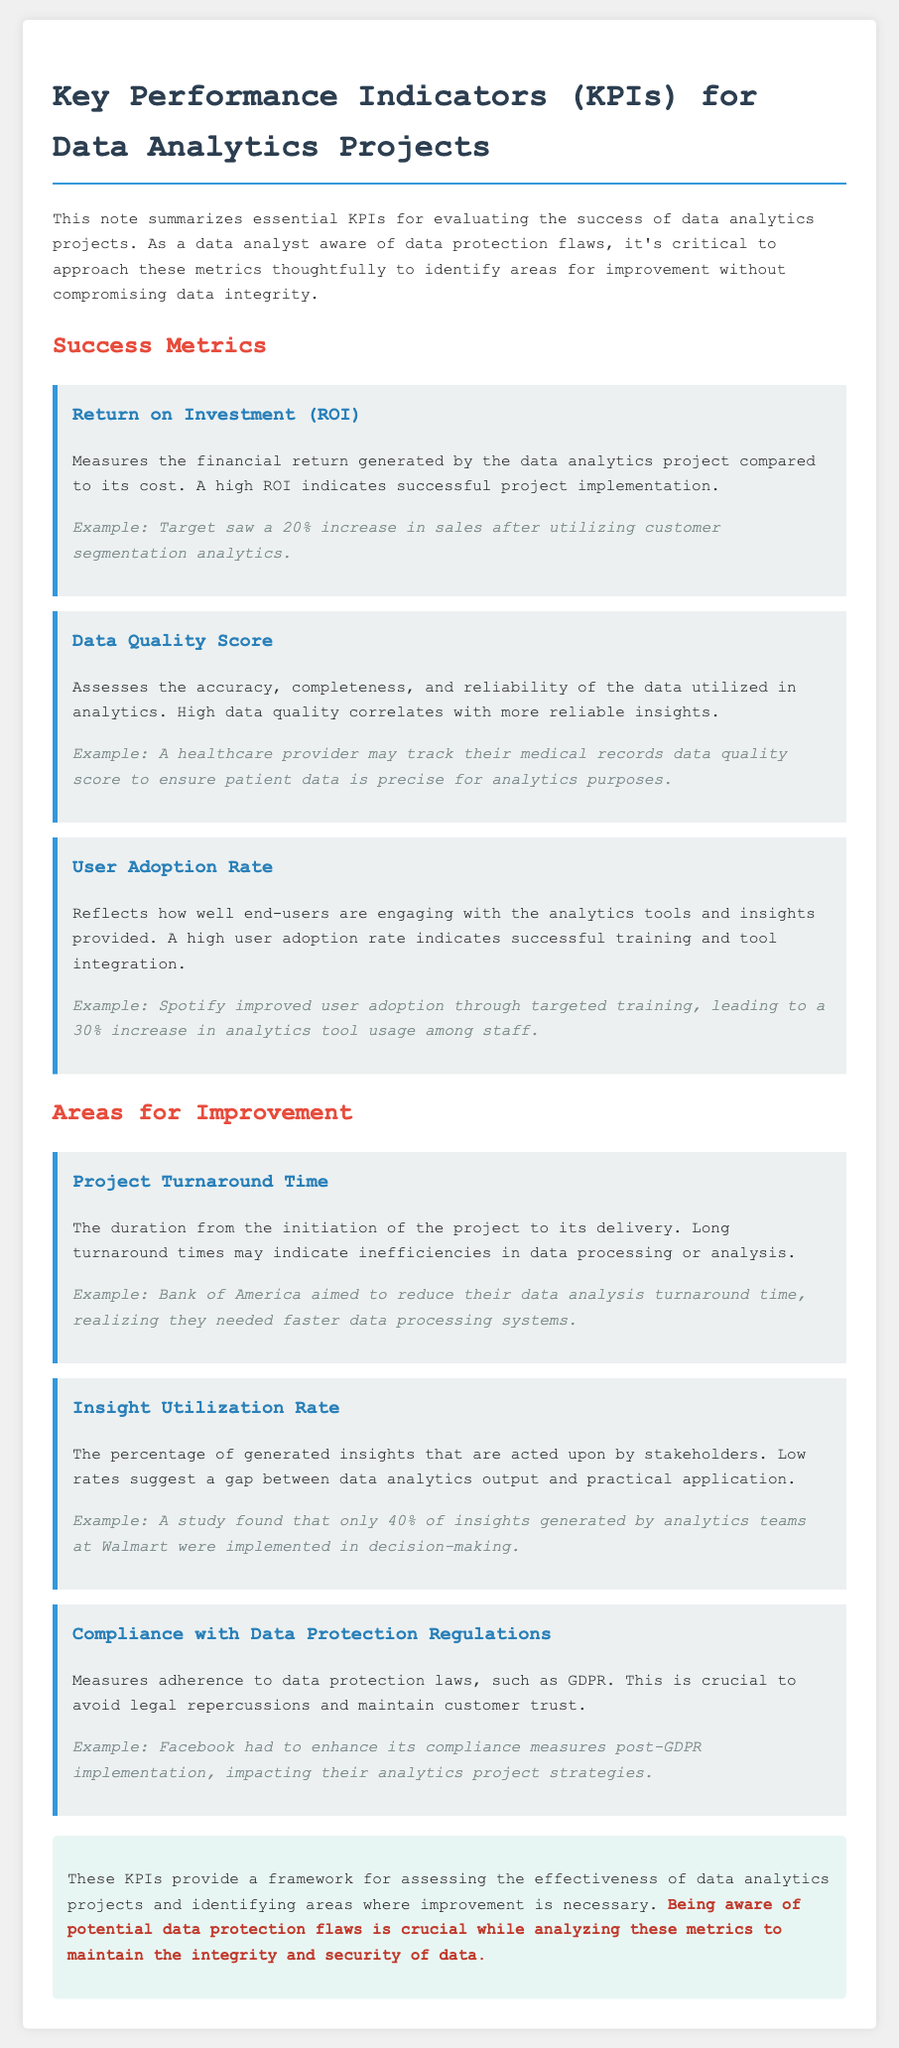What are the two main sections in the document? The document is divided into two main sections: "Success Metrics" and "Areas for Improvement."
Answer: Success Metrics and Areas for Improvement What defines a high Return on Investment (ROI)? A high ROI indicates successful project implementation in relation to the project's cost.
Answer: Successful project implementation What does the Data Quality Score assess? The Data Quality Score assesses the accuracy, completeness, and reliability of the data utilized in analytics.
Answer: Accuracy, completeness, and reliability What was the insight utilization rate mentioned for Walmart? The study found that only 40% of insights generated by analytics teams at Walmart were implemented in decision-making.
Answer: 40% What is a key reason for measuring compliance with data protection regulations? This is crucial to avoid legal repercussions and maintain customer trust.
Answer: Avoiding legal repercussions Who saw a 20% increase in sales? Target saw a 20% increase in sales after utilizing customer segmentation analytics.
Answer: Target What can long project turnaround times indicate? Long turnaround times may indicate inefficiencies in data processing or analysis.
Answer: Inefficiencies in data processing What is critical while analyzing KPIs according to the conclusion? Being aware of potential data protection flaws is crucial while analyzing these metrics.
Answer: Awareness of potential data protection flaws 